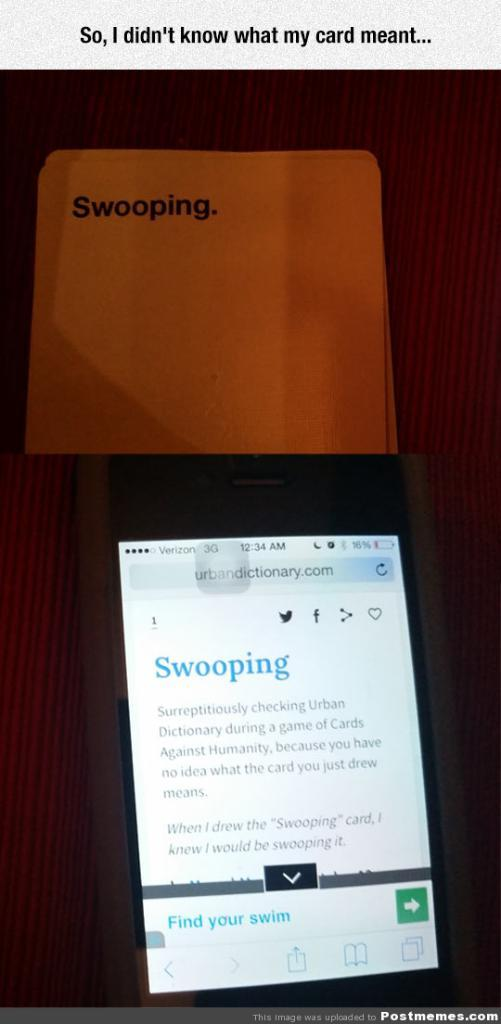<image>
Write a terse but informative summary of the picture. a phone lying on a table with swooping on the screen 